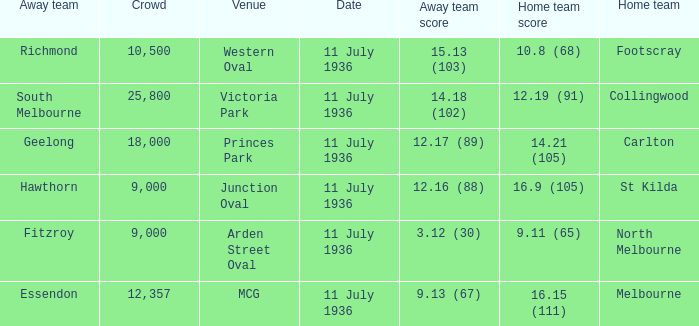What Away team got a team score of 12.16 (88)? Hawthorn. 